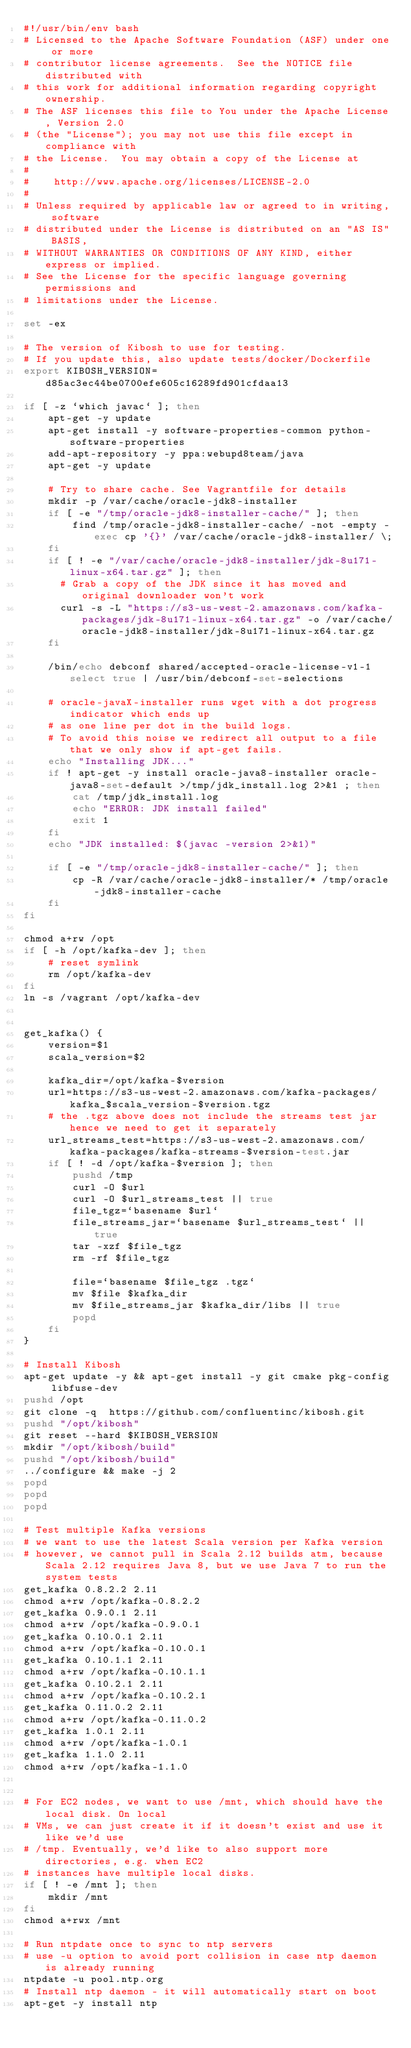<code> <loc_0><loc_0><loc_500><loc_500><_Bash_>#!/usr/bin/env bash
# Licensed to the Apache Software Foundation (ASF) under one or more
# contributor license agreements.  See the NOTICE file distributed with
# this work for additional information regarding copyright ownership.
# The ASF licenses this file to You under the Apache License, Version 2.0
# (the "License"); you may not use this file except in compliance with
# the License.  You may obtain a copy of the License at
#
#    http://www.apache.org/licenses/LICENSE-2.0
#
# Unless required by applicable law or agreed to in writing, software
# distributed under the License is distributed on an "AS IS" BASIS,
# WITHOUT WARRANTIES OR CONDITIONS OF ANY KIND, either express or implied.
# See the License for the specific language governing permissions and
# limitations under the License.

set -ex

# The version of Kibosh to use for testing.
# If you update this, also update tests/docker/Dockerfile
export KIBOSH_VERSION=d85ac3ec44be0700efe605c16289fd901cfdaa13

if [ -z `which javac` ]; then
    apt-get -y update
    apt-get install -y software-properties-common python-software-properties
    add-apt-repository -y ppa:webupd8team/java
    apt-get -y update

    # Try to share cache. See Vagrantfile for details
    mkdir -p /var/cache/oracle-jdk8-installer
    if [ -e "/tmp/oracle-jdk8-installer-cache/" ]; then
        find /tmp/oracle-jdk8-installer-cache/ -not -empty -exec cp '{}' /var/cache/oracle-jdk8-installer/ \;
    fi
    if [ ! -e "/var/cache/oracle-jdk8-installer/jdk-8u171-linux-x64.tar.gz" ]; then
      # Grab a copy of the JDK since it has moved and original downloader won't work
      curl -s -L "https://s3-us-west-2.amazonaws.com/kafka-packages/jdk-8u171-linux-x64.tar.gz" -o /var/cache/oracle-jdk8-installer/jdk-8u171-linux-x64.tar.gz
    fi

    /bin/echo debconf shared/accepted-oracle-license-v1-1 select true | /usr/bin/debconf-set-selections

    # oracle-javaX-installer runs wget with a dot progress indicator which ends up
    # as one line per dot in the build logs.
    # To avoid this noise we redirect all output to a file that we only show if apt-get fails.
    echo "Installing JDK..."
    if ! apt-get -y install oracle-java8-installer oracle-java8-set-default >/tmp/jdk_install.log 2>&1 ; then
        cat /tmp/jdk_install.log
        echo "ERROR: JDK install failed"
        exit 1
    fi
    echo "JDK installed: $(javac -version 2>&1)"

    if [ -e "/tmp/oracle-jdk8-installer-cache/" ]; then
        cp -R /var/cache/oracle-jdk8-installer/* /tmp/oracle-jdk8-installer-cache
    fi
fi

chmod a+rw /opt
if [ -h /opt/kafka-dev ]; then
    # reset symlink
    rm /opt/kafka-dev
fi
ln -s /vagrant /opt/kafka-dev


get_kafka() {
    version=$1
    scala_version=$2

    kafka_dir=/opt/kafka-$version
    url=https://s3-us-west-2.amazonaws.com/kafka-packages/kafka_$scala_version-$version.tgz
    # the .tgz above does not include the streams test jar hence we need to get it separately
    url_streams_test=https://s3-us-west-2.amazonaws.com/kafka-packages/kafka-streams-$version-test.jar
    if [ ! -d /opt/kafka-$version ]; then
        pushd /tmp
        curl -O $url
        curl -O $url_streams_test || true
        file_tgz=`basename $url`
        file_streams_jar=`basename $url_streams_test` || true
        tar -xzf $file_tgz
        rm -rf $file_tgz

        file=`basename $file_tgz .tgz`
        mv $file $kafka_dir
        mv $file_streams_jar $kafka_dir/libs || true
        popd
    fi
}

# Install Kibosh
apt-get update -y && apt-get install -y git cmake pkg-config libfuse-dev
pushd /opt
git clone -q  https://github.com/confluentinc/kibosh.git
pushd "/opt/kibosh"
git reset --hard $KIBOSH_VERSION
mkdir "/opt/kibosh/build"
pushd "/opt/kibosh/build"
../configure && make -j 2
popd
popd
popd

# Test multiple Kafka versions
# we want to use the latest Scala version per Kafka version
# however, we cannot pull in Scala 2.12 builds atm, because Scala 2.12 requires Java 8, but we use Java 7 to run the system tests
get_kafka 0.8.2.2 2.11
chmod a+rw /opt/kafka-0.8.2.2
get_kafka 0.9.0.1 2.11
chmod a+rw /opt/kafka-0.9.0.1
get_kafka 0.10.0.1 2.11
chmod a+rw /opt/kafka-0.10.0.1
get_kafka 0.10.1.1 2.11
chmod a+rw /opt/kafka-0.10.1.1
get_kafka 0.10.2.1 2.11
chmod a+rw /opt/kafka-0.10.2.1
get_kafka 0.11.0.2 2.11
chmod a+rw /opt/kafka-0.11.0.2
get_kafka 1.0.1 2.11
chmod a+rw /opt/kafka-1.0.1
get_kafka 1.1.0 2.11
chmod a+rw /opt/kafka-1.1.0


# For EC2 nodes, we want to use /mnt, which should have the local disk. On local
# VMs, we can just create it if it doesn't exist and use it like we'd use
# /tmp. Eventually, we'd like to also support more directories, e.g. when EC2
# instances have multiple local disks.
if [ ! -e /mnt ]; then
    mkdir /mnt
fi
chmod a+rwx /mnt

# Run ntpdate once to sync to ntp servers
# use -u option to avoid port collision in case ntp daemon is already running
ntpdate -u pool.ntp.org
# Install ntp daemon - it will automatically start on boot
apt-get -y install ntp
</code> 